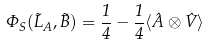Convert formula to latex. <formula><loc_0><loc_0><loc_500><loc_500>\Phi _ { S } ( \vec { L } _ { A } , \vec { B } ) = \frac { 1 } { 4 } - \frac { 1 } { 4 } \langle \hat { A } \otimes \hat { V } \rangle</formula> 